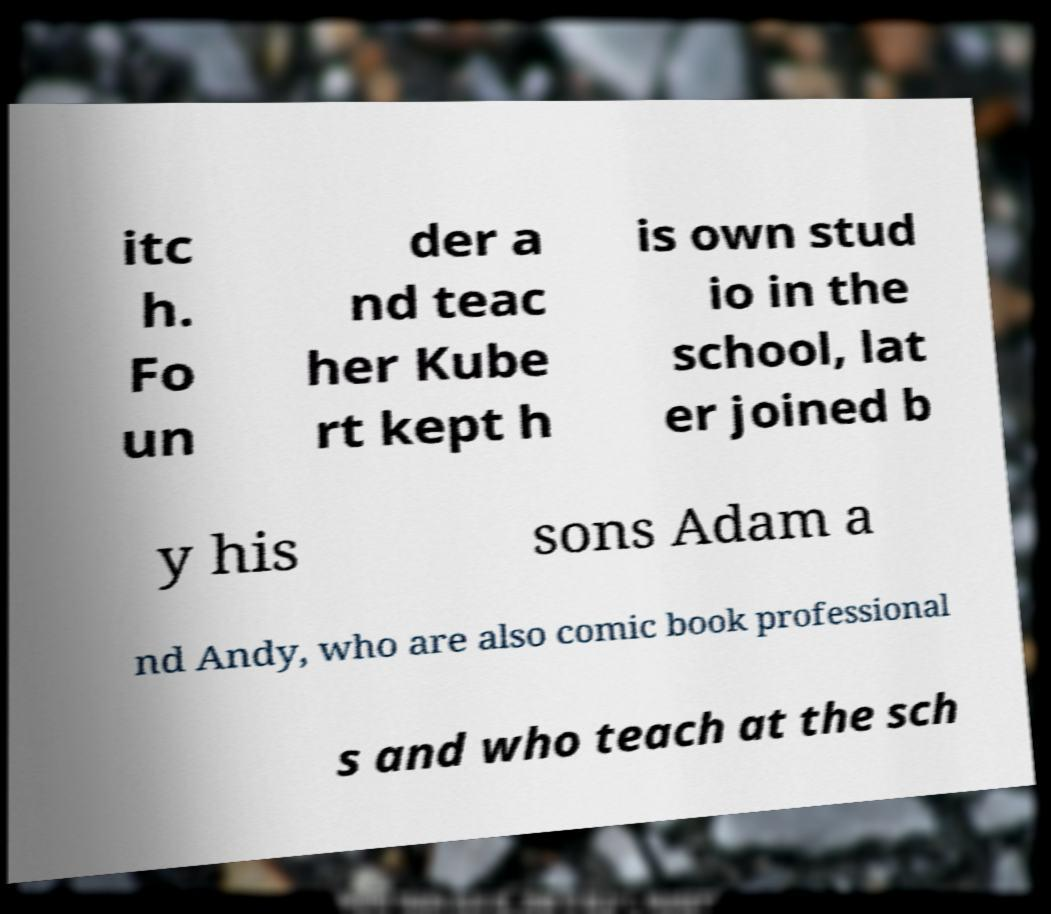Could you extract and type out the text from this image? itc h. Fo un der a nd teac her Kube rt kept h is own stud io in the school, lat er joined b y his sons Adam a nd Andy, who are also comic book professional s and who teach at the sch 